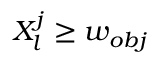<formula> <loc_0><loc_0><loc_500><loc_500>X _ { l } ^ { j } \geq w _ { o b j }</formula> 